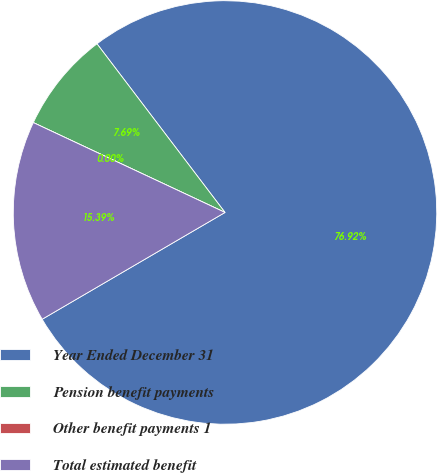Convert chart to OTSL. <chart><loc_0><loc_0><loc_500><loc_500><pie_chart><fcel>Year Ended December 31<fcel>Pension benefit payments<fcel>Other benefit payments 1<fcel>Total estimated benefit<nl><fcel>76.92%<fcel>7.69%<fcel>0.0%<fcel>15.39%<nl></chart> 